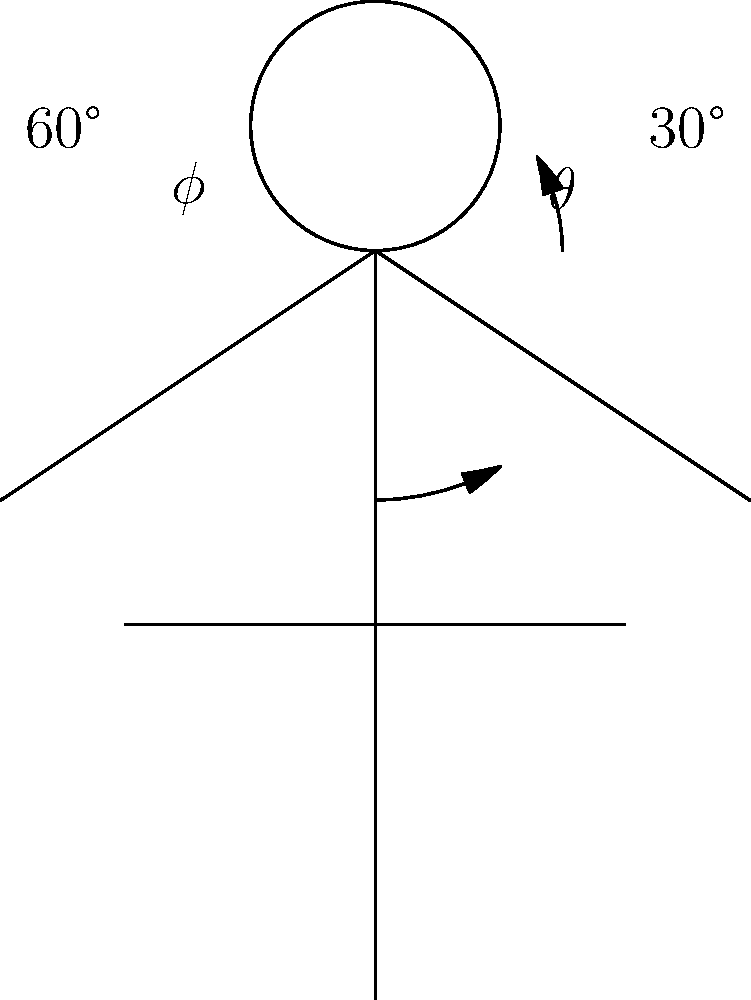As a software engineer involved in tech-based community initiatives at your church, you're assessing the ergonomics of using tablets for Bible study. In the diagram, $\theta$ represents the forward head tilt angle, and $\phi$ represents the downward gaze angle when using a tablet. Given that $\theta = 30°$ and $\phi = 60°$, what is the recommended maximum duration (in minutes) for maintaining this posture during a Bible study session to avoid neck strain? To determine the recommended maximum duration for maintaining this posture, we need to consider ergonomic guidelines for neck posture:

1. The neutral position for the neck is with the head balanced directly above the shoulders, with a 0° forward head tilt.

2. As the forward head tilt ($\theta$) increases, the stress on the neck muscles and spine increases exponentially.

3. The downward gaze angle ($\phi$) also contributes to neck strain, as it often correlates with increased forward head tilt.

4. Ergonomic guidelines suggest:
   - For $\theta \leq 15°$: up to 1 hour of continuous use
   - For $15° < \theta \leq 25°$: up to 30 minutes of continuous use
   - For $25° < \theta \leq 45°$: no more than 15 minutes of continuous use
   - For $\theta > 45°$: should be avoided

5. In this case, $\theta = 30°$, which falls in the range of 25° < $\theta$ ≤ 45°.

6. The large downward gaze angle ($\phi = 60°$) further increases the risk of neck strain.

7. Given these factors, the recommended maximum duration should be at the lower end of the 15-minute guideline for the 25° < $\theta$ ≤ 45° range.

Therefore, the recommended maximum duration for maintaining this posture during a Bible study session would be 10 minutes, after which a break or posture change is advised.
Answer: 10 minutes 